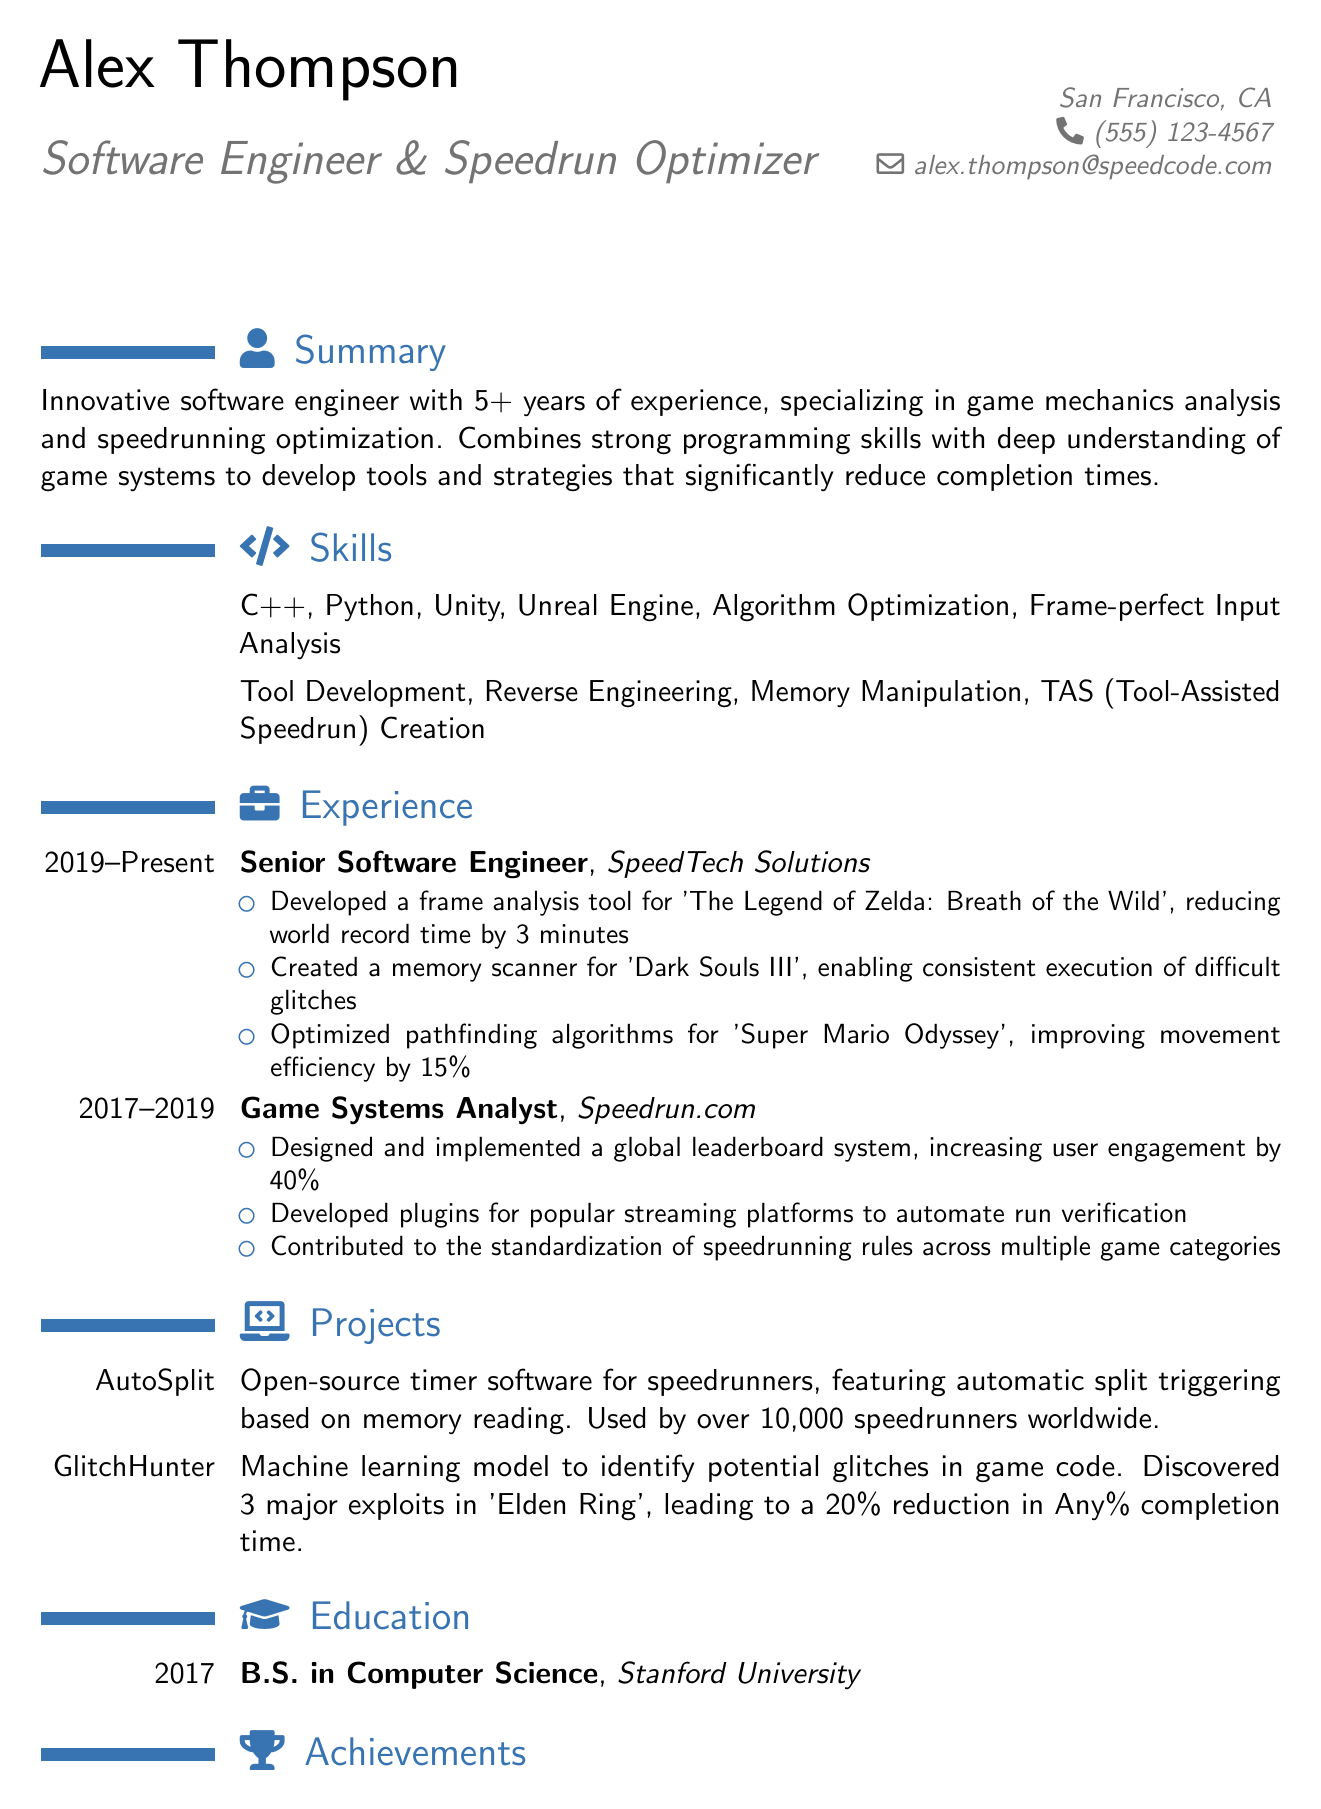What is the name of the individual? The document states the name at the top, which is Alex Thompson.
Answer: Alex Thompson What degree did Alex Thompson earn? The education section specifies the degree earned as a B.S. in Computer Science.
Answer: B.S. in Computer Science How many years of experience does Alex have? The summary mentions 5+ years of experience in the field.
Answer: 5+ years What is the impact of the AutoSplit project? The project description states it is used by over 10,000 speedrunners worldwide.
Answer: Used by over 10,000 speedrunners worldwide Which game did Alex hold a world record for? The achievements section lists the game for which the world record was held, which is Hades.
Answer: Hades What was one of the achievements at Speedrun.com? The document lists several achievements, one of which is designing a global leaderboard system.
Answer: Designed a global leaderboard system What programming languages is Alex proficient in? The skills section lists several programming languages, including C++ and Python as examples.
Answer: C++, Python How much did the frame analysis tool reduce world record time by? The experience section specifies a 3-minute reduction in world record time.
Answer: 3 minutes What is the name of the machine learning model project? The project section identifies the model as GlitchHunter.
Answer: GlitchHunter 